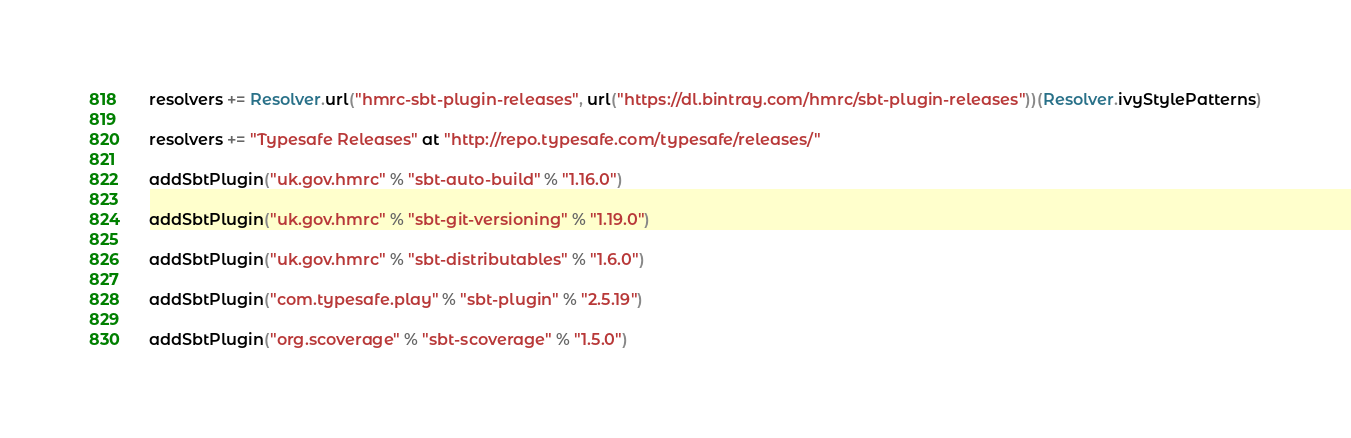Convert code to text. <code><loc_0><loc_0><loc_500><loc_500><_Scala_>resolvers += Resolver.url("hmrc-sbt-plugin-releases", url("https://dl.bintray.com/hmrc/sbt-plugin-releases"))(Resolver.ivyStylePatterns)

resolvers += "Typesafe Releases" at "http://repo.typesafe.com/typesafe/releases/"

addSbtPlugin("uk.gov.hmrc" % "sbt-auto-build" % "1.16.0")

addSbtPlugin("uk.gov.hmrc" % "sbt-git-versioning" % "1.19.0")

addSbtPlugin("uk.gov.hmrc" % "sbt-distributables" % "1.6.0")

addSbtPlugin("com.typesafe.play" % "sbt-plugin" % "2.5.19")

addSbtPlugin("org.scoverage" % "sbt-scoverage" % "1.5.0")
</code> 